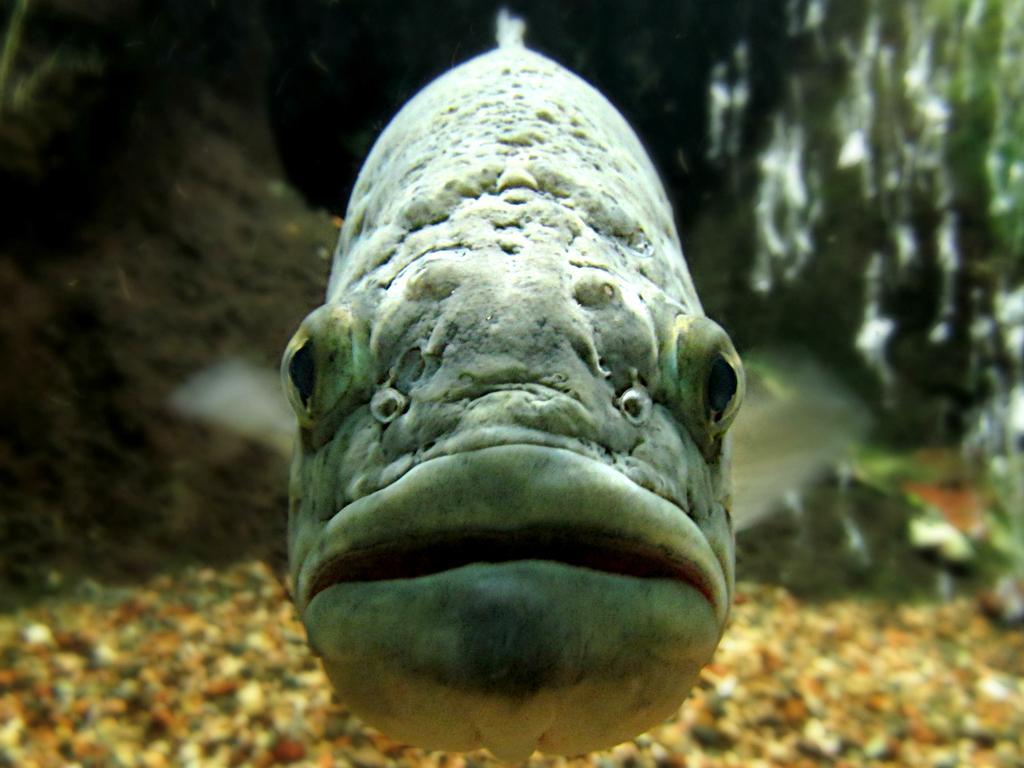Describe this image in one or two sentences. In this picture we can see a fish, stones and in the background we can see some objects. 